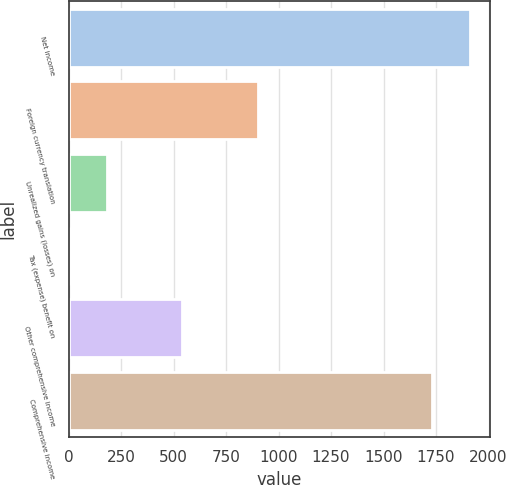<chart> <loc_0><loc_0><loc_500><loc_500><bar_chart><fcel>Net income<fcel>Foreign currency translation<fcel>Unrealized gains (losses) on<fcel>Tax (expense) benefit on<fcel>Other comprehensive income<fcel>Comprehensive income<nl><fcel>1913<fcel>901<fcel>181<fcel>1<fcel>541<fcel>1733<nl></chart> 